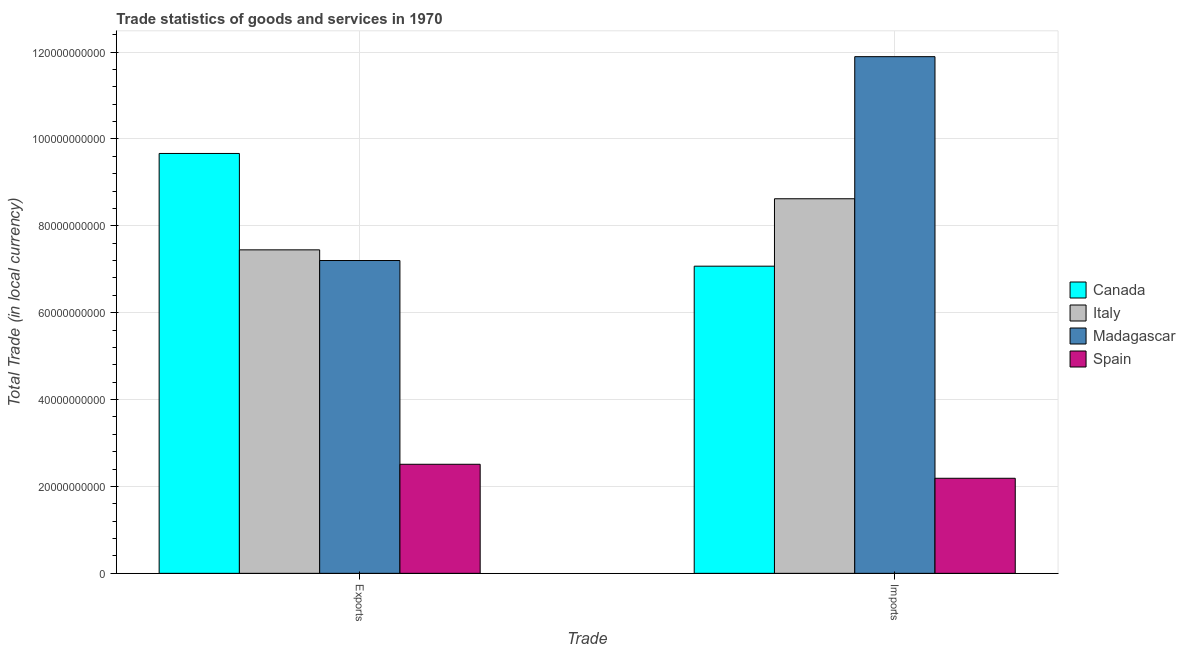Are the number of bars on each tick of the X-axis equal?
Offer a terse response. Yes. How many bars are there on the 1st tick from the left?
Your answer should be compact. 4. What is the label of the 2nd group of bars from the left?
Your response must be concise. Imports. What is the imports of goods and services in Madagascar?
Make the answer very short. 1.19e+11. Across all countries, what is the maximum imports of goods and services?
Your answer should be compact. 1.19e+11. Across all countries, what is the minimum export of goods and services?
Offer a very short reply. 2.51e+1. What is the total imports of goods and services in the graph?
Your response must be concise. 2.98e+11. What is the difference between the export of goods and services in Canada and that in Italy?
Provide a succinct answer. 2.22e+1. What is the difference between the export of goods and services in Italy and the imports of goods and services in Madagascar?
Give a very brief answer. -4.45e+1. What is the average imports of goods and services per country?
Your response must be concise. 7.44e+1. What is the difference between the export of goods and services and imports of goods and services in Spain?
Give a very brief answer. 3.22e+09. In how many countries, is the export of goods and services greater than 40000000000 LCU?
Keep it short and to the point. 3. What is the ratio of the imports of goods and services in Spain to that in Canada?
Keep it short and to the point. 0.31. In how many countries, is the export of goods and services greater than the average export of goods and services taken over all countries?
Make the answer very short. 3. What does the 4th bar from the right in Exports represents?
Offer a terse response. Canada. How many bars are there?
Ensure brevity in your answer.  8. Where does the legend appear in the graph?
Ensure brevity in your answer.  Center right. How are the legend labels stacked?
Your answer should be very brief. Vertical. What is the title of the graph?
Your response must be concise. Trade statistics of goods and services in 1970. What is the label or title of the X-axis?
Keep it short and to the point. Trade. What is the label or title of the Y-axis?
Provide a succinct answer. Total Trade (in local currency). What is the Total Trade (in local currency) of Canada in Exports?
Your response must be concise. 9.66e+1. What is the Total Trade (in local currency) in Italy in Exports?
Provide a short and direct response. 7.45e+1. What is the Total Trade (in local currency) of Madagascar in Exports?
Your response must be concise. 7.20e+1. What is the Total Trade (in local currency) in Spain in Exports?
Provide a succinct answer. 2.51e+1. What is the Total Trade (in local currency) of Canada in Imports?
Ensure brevity in your answer.  7.07e+1. What is the Total Trade (in local currency) in Italy in Imports?
Your answer should be very brief. 8.62e+1. What is the Total Trade (in local currency) in Madagascar in Imports?
Give a very brief answer. 1.19e+11. What is the Total Trade (in local currency) in Spain in Imports?
Offer a very short reply. 2.19e+1. Across all Trade, what is the maximum Total Trade (in local currency) in Canada?
Offer a terse response. 9.66e+1. Across all Trade, what is the maximum Total Trade (in local currency) in Italy?
Your answer should be compact. 8.62e+1. Across all Trade, what is the maximum Total Trade (in local currency) in Madagascar?
Offer a very short reply. 1.19e+11. Across all Trade, what is the maximum Total Trade (in local currency) in Spain?
Make the answer very short. 2.51e+1. Across all Trade, what is the minimum Total Trade (in local currency) of Canada?
Ensure brevity in your answer.  7.07e+1. Across all Trade, what is the minimum Total Trade (in local currency) in Italy?
Your answer should be very brief. 7.45e+1. Across all Trade, what is the minimum Total Trade (in local currency) of Madagascar?
Keep it short and to the point. 7.20e+1. Across all Trade, what is the minimum Total Trade (in local currency) in Spain?
Your answer should be very brief. 2.19e+1. What is the total Total Trade (in local currency) of Canada in the graph?
Offer a very short reply. 1.67e+11. What is the total Total Trade (in local currency) of Italy in the graph?
Offer a terse response. 1.61e+11. What is the total Total Trade (in local currency) of Madagascar in the graph?
Keep it short and to the point. 1.91e+11. What is the total Total Trade (in local currency) of Spain in the graph?
Offer a very short reply. 4.70e+1. What is the difference between the Total Trade (in local currency) in Canada in Exports and that in Imports?
Keep it short and to the point. 2.59e+1. What is the difference between the Total Trade (in local currency) in Italy in Exports and that in Imports?
Offer a terse response. -1.18e+1. What is the difference between the Total Trade (in local currency) in Madagascar in Exports and that in Imports?
Provide a short and direct response. -4.69e+1. What is the difference between the Total Trade (in local currency) in Spain in Exports and that in Imports?
Your answer should be compact. 3.22e+09. What is the difference between the Total Trade (in local currency) in Canada in Exports and the Total Trade (in local currency) in Italy in Imports?
Ensure brevity in your answer.  1.04e+1. What is the difference between the Total Trade (in local currency) of Canada in Exports and the Total Trade (in local currency) of Madagascar in Imports?
Your answer should be compact. -2.23e+1. What is the difference between the Total Trade (in local currency) in Canada in Exports and the Total Trade (in local currency) in Spain in Imports?
Your answer should be compact. 7.48e+1. What is the difference between the Total Trade (in local currency) of Italy in Exports and the Total Trade (in local currency) of Madagascar in Imports?
Ensure brevity in your answer.  -4.45e+1. What is the difference between the Total Trade (in local currency) of Italy in Exports and the Total Trade (in local currency) of Spain in Imports?
Keep it short and to the point. 5.26e+1. What is the difference between the Total Trade (in local currency) in Madagascar in Exports and the Total Trade (in local currency) in Spain in Imports?
Your answer should be compact. 5.01e+1. What is the average Total Trade (in local currency) of Canada per Trade?
Give a very brief answer. 8.37e+1. What is the average Total Trade (in local currency) of Italy per Trade?
Your answer should be very brief. 8.03e+1. What is the average Total Trade (in local currency) of Madagascar per Trade?
Offer a terse response. 9.55e+1. What is the average Total Trade (in local currency) of Spain per Trade?
Offer a terse response. 2.35e+1. What is the difference between the Total Trade (in local currency) of Canada and Total Trade (in local currency) of Italy in Exports?
Make the answer very short. 2.22e+1. What is the difference between the Total Trade (in local currency) in Canada and Total Trade (in local currency) in Madagascar in Exports?
Ensure brevity in your answer.  2.46e+1. What is the difference between the Total Trade (in local currency) of Canada and Total Trade (in local currency) of Spain in Exports?
Provide a succinct answer. 7.15e+1. What is the difference between the Total Trade (in local currency) of Italy and Total Trade (in local currency) of Madagascar in Exports?
Offer a very short reply. 2.45e+09. What is the difference between the Total Trade (in local currency) of Italy and Total Trade (in local currency) of Spain in Exports?
Keep it short and to the point. 4.94e+1. What is the difference between the Total Trade (in local currency) of Madagascar and Total Trade (in local currency) of Spain in Exports?
Keep it short and to the point. 4.69e+1. What is the difference between the Total Trade (in local currency) in Canada and Total Trade (in local currency) in Italy in Imports?
Give a very brief answer. -1.55e+1. What is the difference between the Total Trade (in local currency) of Canada and Total Trade (in local currency) of Madagascar in Imports?
Ensure brevity in your answer.  -4.82e+1. What is the difference between the Total Trade (in local currency) of Canada and Total Trade (in local currency) of Spain in Imports?
Your response must be concise. 4.88e+1. What is the difference between the Total Trade (in local currency) of Italy and Total Trade (in local currency) of Madagascar in Imports?
Your answer should be compact. -3.27e+1. What is the difference between the Total Trade (in local currency) in Italy and Total Trade (in local currency) in Spain in Imports?
Offer a terse response. 6.43e+1. What is the difference between the Total Trade (in local currency) of Madagascar and Total Trade (in local currency) of Spain in Imports?
Your answer should be very brief. 9.70e+1. What is the ratio of the Total Trade (in local currency) of Canada in Exports to that in Imports?
Make the answer very short. 1.37. What is the ratio of the Total Trade (in local currency) of Italy in Exports to that in Imports?
Keep it short and to the point. 0.86. What is the ratio of the Total Trade (in local currency) of Madagascar in Exports to that in Imports?
Ensure brevity in your answer.  0.61. What is the ratio of the Total Trade (in local currency) of Spain in Exports to that in Imports?
Your response must be concise. 1.15. What is the difference between the highest and the second highest Total Trade (in local currency) in Canada?
Give a very brief answer. 2.59e+1. What is the difference between the highest and the second highest Total Trade (in local currency) in Italy?
Give a very brief answer. 1.18e+1. What is the difference between the highest and the second highest Total Trade (in local currency) of Madagascar?
Give a very brief answer. 4.69e+1. What is the difference between the highest and the second highest Total Trade (in local currency) in Spain?
Your response must be concise. 3.22e+09. What is the difference between the highest and the lowest Total Trade (in local currency) in Canada?
Offer a terse response. 2.59e+1. What is the difference between the highest and the lowest Total Trade (in local currency) of Italy?
Provide a succinct answer. 1.18e+1. What is the difference between the highest and the lowest Total Trade (in local currency) in Madagascar?
Your response must be concise. 4.69e+1. What is the difference between the highest and the lowest Total Trade (in local currency) of Spain?
Offer a very short reply. 3.22e+09. 